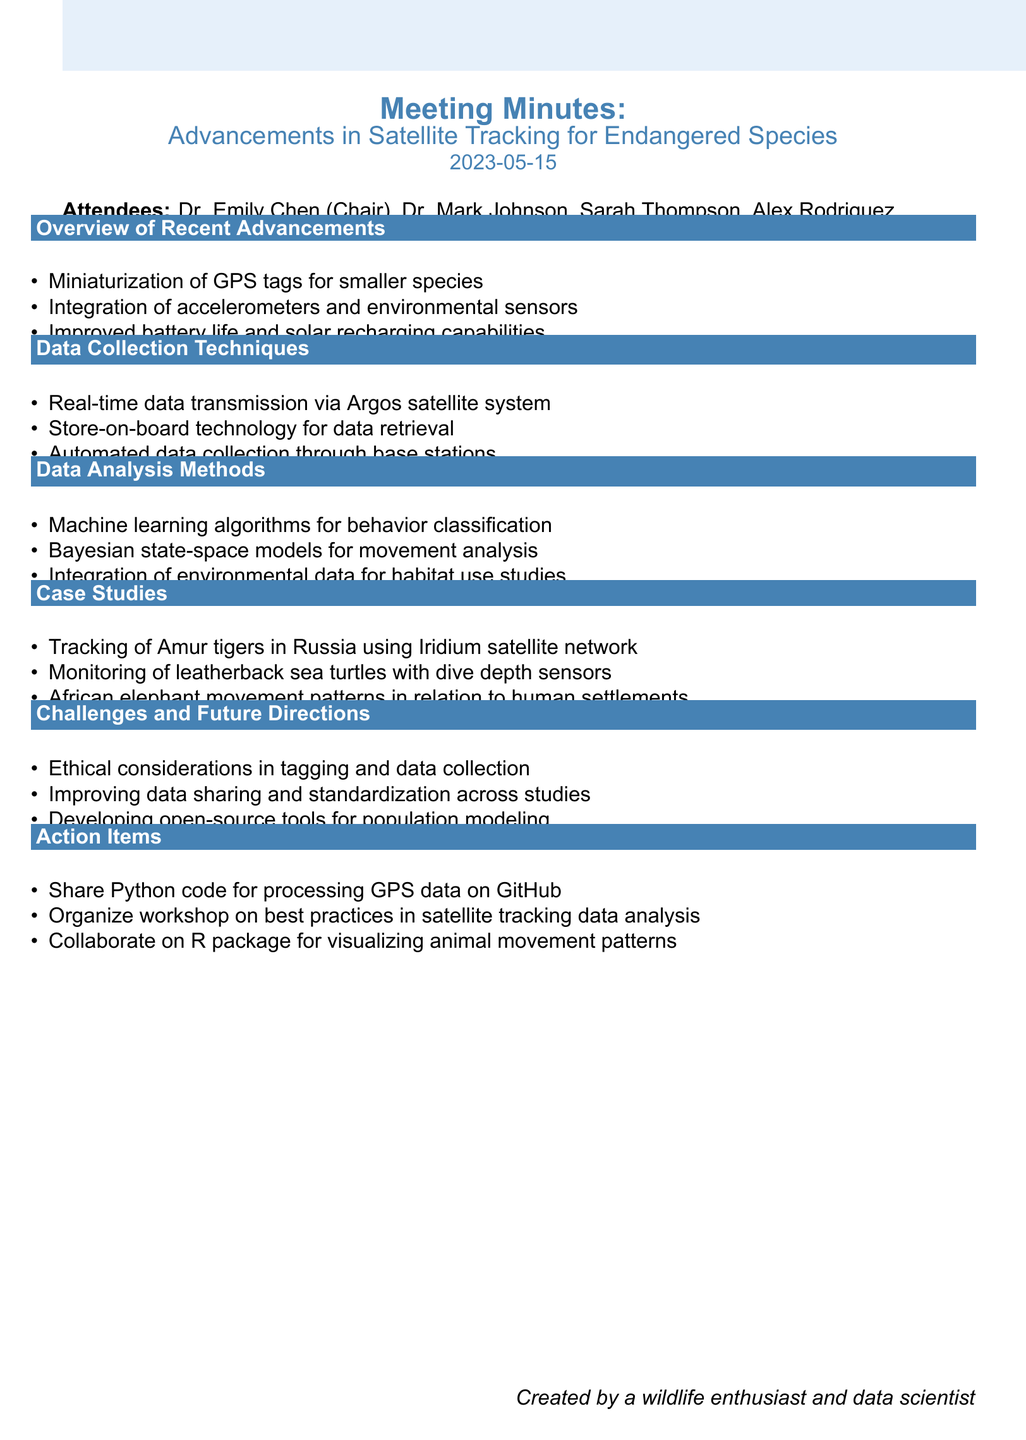What was the date of the meeting? The date of the meeting is mentioned at the beginning of the document.
Answer: 2023-05-15 Who chaired the meeting? The document lists the attendees and indicates who was the chair of the meeting.
Answer: Dr. Emily Chen What is one recent advancement in satellite tracking mentioned? The section on advancements in technology lists specific improvements.
Answer: Miniaturization of GPS tags for smaller species Which data collection technique allows for real-time transmission? The document specifies various data collection techniques, including one that allows real-time data transmission.
Answer: Argos satellite system What type of model is used for movement analysis? The methods for data analysis detail several models used, including one mentioned.
Answer: Bayesian state-space models How many case studies are mentioned in the document? The case studies section lists specific examples, providing a total count.
Answer: Three What is one ethical challenge mentioned regarding data collection? The document addresses challenges, including ethical considerations in data collection.
Answer: Ethical considerations What is one action item from the meeting? The action items section lists tasks discussed during the meeting, indicating specific actions.
Answer: Share Python code for processing GPS data on GitHub 